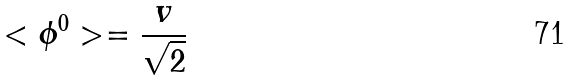<formula> <loc_0><loc_0><loc_500><loc_500>< \phi ^ { 0 } > = \frac { v } { \sqrt { 2 } }</formula> 